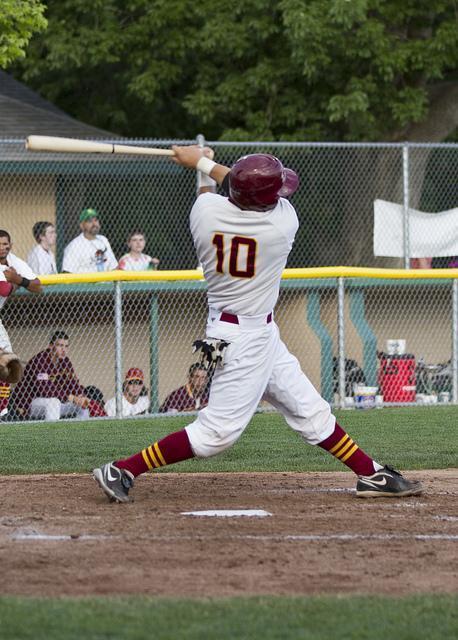How many people are there?
Give a very brief answer. 3. 